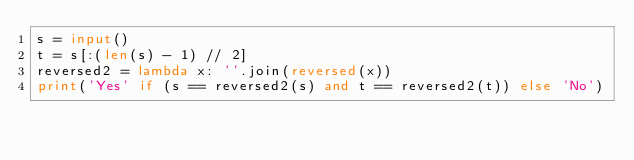<code> <loc_0><loc_0><loc_500><loc_500><_Python_>s = input()
t = s[:(len(s) - 1) // 2]
reversed2 = lambda x: ''.join(reversed(x))
print('Yes' if (s == reversed2(s) and t == reversed2(t)) else 'No')</code> 